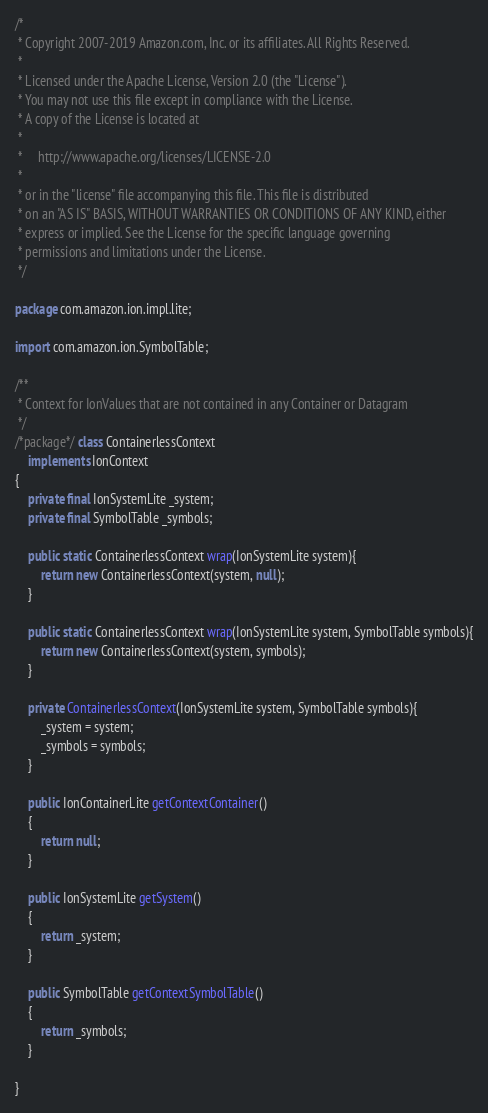Convert code to text. <code><loc_0><loc_0><loc_500><loc_500><_Java_>/*
 * Copyright 2007-2019 Amazon.com, Inc. or its affiliates. All Rights Reserved.
 *
 * Licensed under the Apache License, Version 2.0 (the "License").
 * You may not use this file except in compliance with the License.
 * A copy of the License is located at
 *
 *     http://www.apache.org/licenses/LICENSE-2.0
 *
 * or in the "license" file accompanying this file. This file is distributed
 * on an "AS IS" BASIS, WITHOUT WARRANTIES OR CONDITIONS OF ANY KIND, either
 * express or implied. See the License for the specific language governing
 * permissions and limitations under the License.
 */

package com.amazon.ion.impl.lite;

import com.amazon.ion.SymbolTable;

/**
 * Context for IonValues that are not contained in any Container or Datagram
 */
/*package*/ class ContainerlessContext
    implements IonContext
{
    private final IonSystemLite _system;
    private final SymbolTable _symbols;

    public static ContainerlessContext wrap(IonSystemLite system){
        return new ContainerlessContext(system, null);
    }

    public static ContainerlessContext wrap(IonSystemLite system, SymbolTable symbols){
        return new ContainerlessContext(system, symbols);
    }

    private ContainerlessContext(IonSystemLite system, SymbolTable symbols){
        _system = system;
        _symbols = symbols;
    }

    public IonContainerLite getContextContainer()
    {
        return null;
    }

    public IonSystemLite getSystem()
    {
        return _system;
    }

    public SymbolTable getContextSymbolTable()
    {
        return _symbols;
    }

}
</code> 